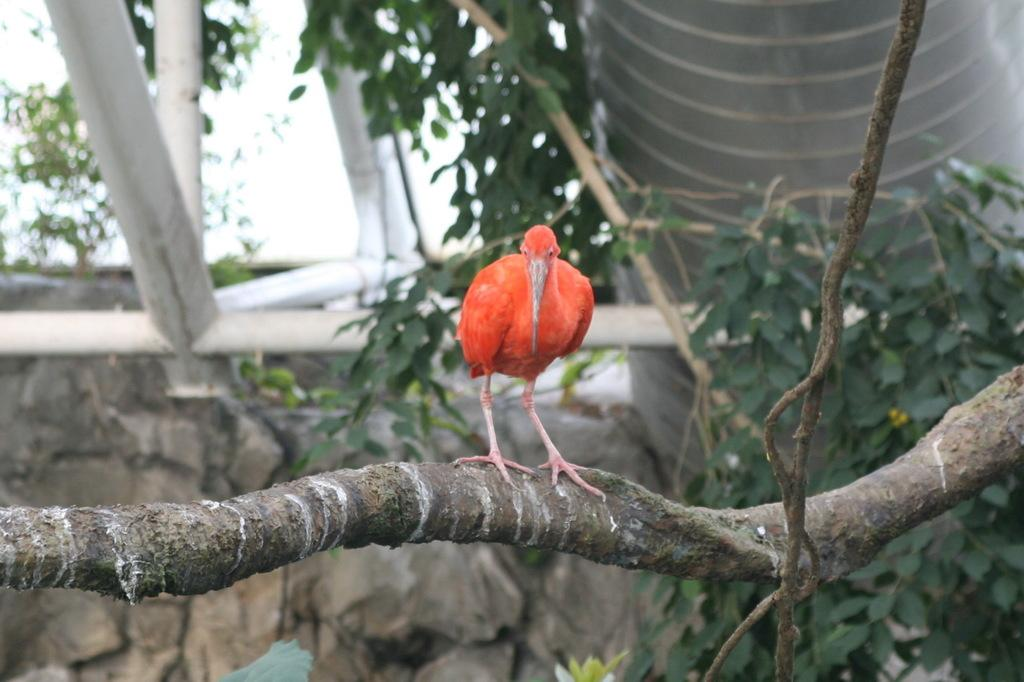What type of animal can be seen in the image? There is a bird in the image. Where is the bird located? The bird is standing on a tree branch. What can be seen in the background of the image? There are plants, a wall, rods, a pipe, and the sky visible in the background of the image. What type of grain is being managed by the plant in the image? There is no plant or grain present in the image; it features a bird standing on a tree branch with various background elements. 